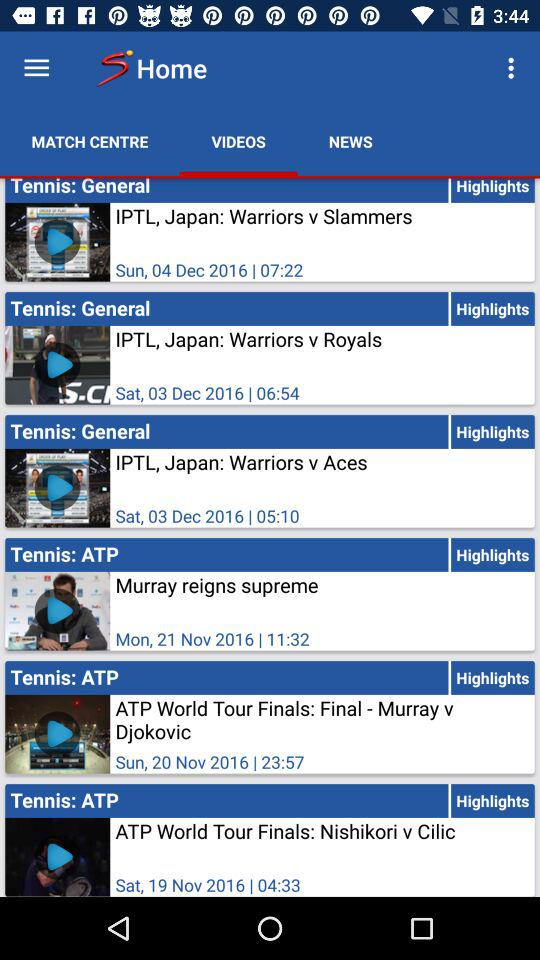How many videos are there in the Tennis: General section?
Answer the question using a single word or phrase. 3 